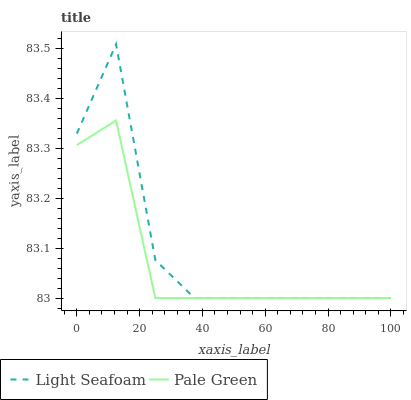Does Pale Green have the minimum area under the curve?
Answer yes or no. Yes. Does Light Seafoam have the maximum area under the curve?
Answer yes or no. Yes. Does Light Seafoam have the minimum area under the curve?
Answer yes or no. No. Is Pale Green the smoothest?
Answer yes or no. Yes. Is Light Seafoam the roughest?
Answer yes or no. Yes. Is Light Seafoam the smoothest?
Answer yes or no. No. Does Pale Green have the lowest value?
Answer yes or no. Yes. Does Light Seafoam have the highest value?
Answer yes or no. Yes. Does Light Seafoam intersect Pale Green?
Answer yes or no. Yes. Is Light Seafoam less than Pale Green?
Answer yes or no. No. Is Light Seafoam greater than Pale Green?
Answer yes or no. No. 